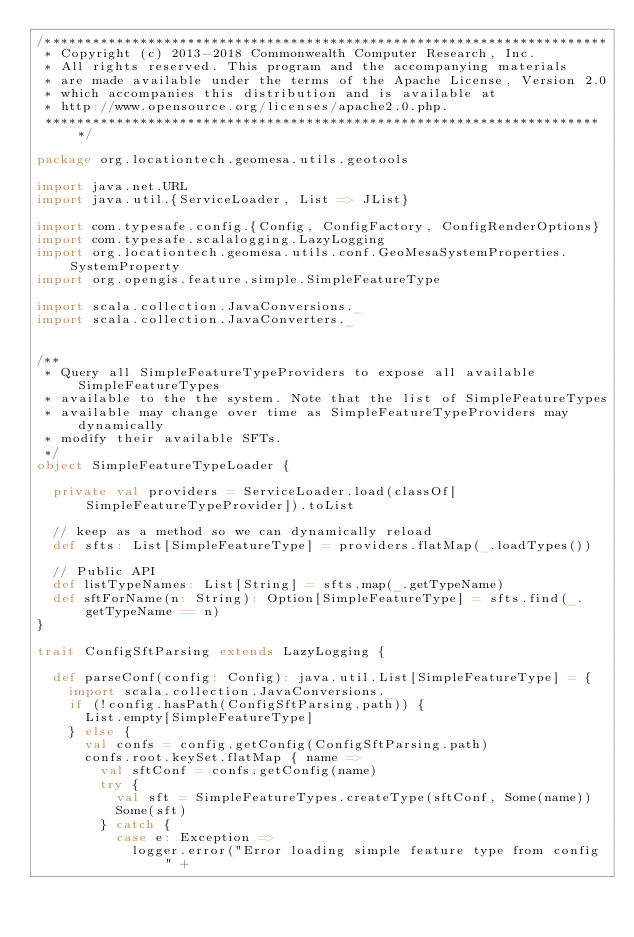Convert code to text. <code><loc_0><loc_0><loc_500><loc_500><_Scala_>/***********************************************************************
 * Copyright (c) 2013-2018 Commonwealth Computer Research, Inc.
 * All rights reserved. This program and the accompanying materials
 * are made available under the terms of the Apache License, Version 2.0
 * which accompanies this distribution and is available at
 * http://www.opensource.org/licenses/apache2.0.php.
 ***********************************************************************/

package org.locationtech.geomesa.utils.geotools

import java.net.URL
import java.util.{ServiceLoader, List => JList}

import com.typesafe.config.{Config, ConfigFactory, ConfigRenderOptions}
import com.typesafe.scalalogging.LazyLogging
import org.locationtech.geomesa.utils.conf.GeoMesaSystemProperties.SystemProperty
import org.opengis.feature.simple.SimpleFeatureType

import scala.collection.JavaConversions._
import scala.collection.JavaConverters._


/**
 * Query all SimpleFeatureTypeProviders to expose all available SimpleFeatureTypes
 * available to the the system. Note that the list of SimpleFeatureTypes
 * available may change over time as SimpleFeatureTypeProviders may dynamically
 * modify their available SFTs.
 */
object SimpleFeatureTypeLoader {

  private val providers = ServiceLoader.load(classOf[SimpleFeatureTypeProvider]).toList

  // keep as a method so we can dynamically reload
  def sfts: List[SimpleFeatureType] = providers.flatMap(_.loadTypes())

  // Public API
  def listTypeNames: List[String] = sfts.map(_.getTypeName)
  def sftForName(n: String): Option[SimpleFeatureType] = sfts.find(_.getTypeName == n)
}

trait ConfigSftParsing extends LazyLogging {

  def parseConf(config: Config): java.util.List[SimpleFeatureType] = {
    import scala.collection.JavaConversions._
    if (!config.hasPath(ConfigSftParsing.path)) {
      List.empty[SimpleFeatureType]
    } else {
      val confs = config.getConfig(ConfigSftParsing.path)
      confs.root.keySet.flatMap { name =>
        val sftConf = confs.getConfig(name)
        try {
          val sft = SimpleFeatureTypes.createType(sftConf, Some(name))
          Some(sft)
        } catch {
          case e: Exception =>
            logger.error("Error loading simple feature type from config " +</code> 